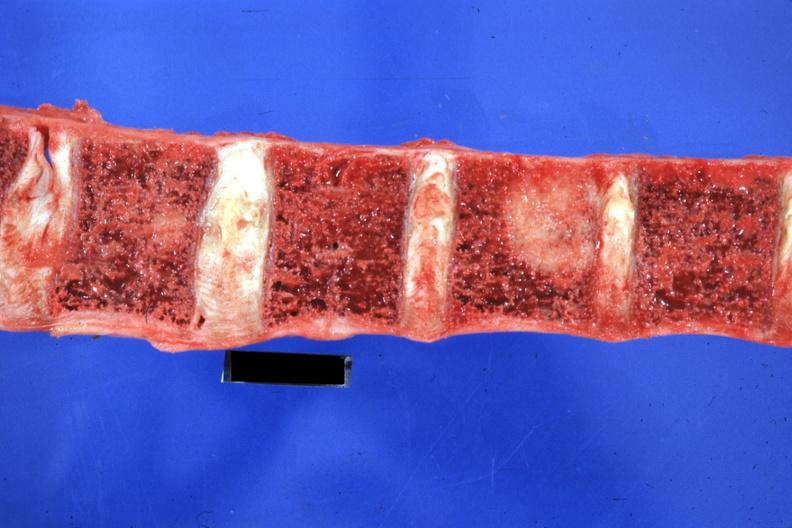s x-ray intramyocardial arteries present?
Answer the question using a single word or phrase. No 